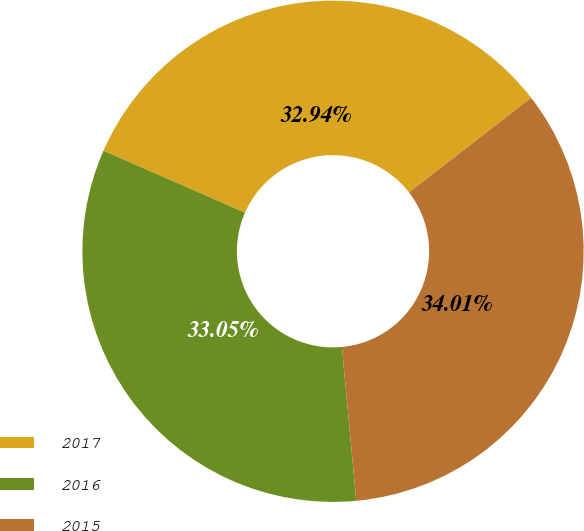Convert chart to OTSL. <chart><loc_0><loc_0><loc_500><loc_500><pie_chart><fcel>2017<fcel>2016<fcel>2015<nl><fcel>32.94%<fcel>33.05%<fcel>34.01%<nl></chart> 